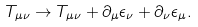<formula> <loc_0><loc_0><loc_500><loc_500>T _ { \mu \nu } \rightarrow T _ { \mu \nu } + \partial _ { \mu } \epsilon _ { \nu } + \partial _ { \nu } \epsilon _ { \mu } .</formula> 